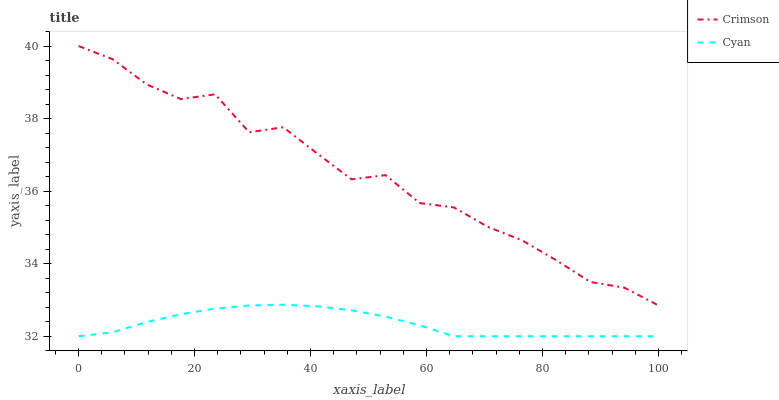Does Cyan have the minimum area under the curve?
Answer yes or no. Yes. Does Crimson have the maximum area under the curve?
Answer yes or no. Yes. Does Cyan have the maximum area under the curve?
Answer yes or no. No. Is Cyan the smoothest?
Answer yes or no. Yes. Is Crimson the roughest?
Answer yes or no. Yes. Is Cyan the roughest?
Answer yes or no. No. Does Cyan have the highest value?
Answer yes or no. No. Is Cyan less than Crimson?
Answer yes or no. Yes. Is Crimson greater than Cyan?
Answer yes or no. Yes. Does Cyan intersect Crimson?
Answer yes or no. No. 